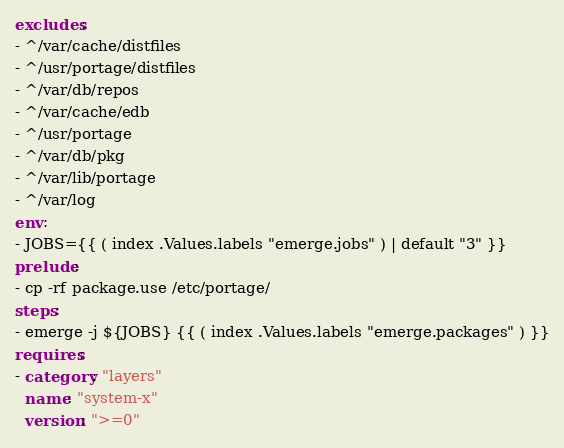<code> <loc_0><loc_0><loc_500><loc_500><_YAML_>excludes:
- ^/var/cache/distfiles
- ^/usr/portage/distfiles
- ^/var/db/repos
- ^/var/cache/edb
- ^/usr/portage
- ^/var/db/pkg
- ^/var/lib/portage
- ^/var/log
env:
- JOBS={{ ( index .Values.labels "emerge.jobs" ) | default "3" }}
prelude:
- cp -rf package.use /etc/portage/
steps:
- emerge -j ${JOBS} {{ ( index .Values.labels "emerge.packages" ) }}
requires:
- category: "layers"
  name: "system-x"
  version: ">=0"
</code> 